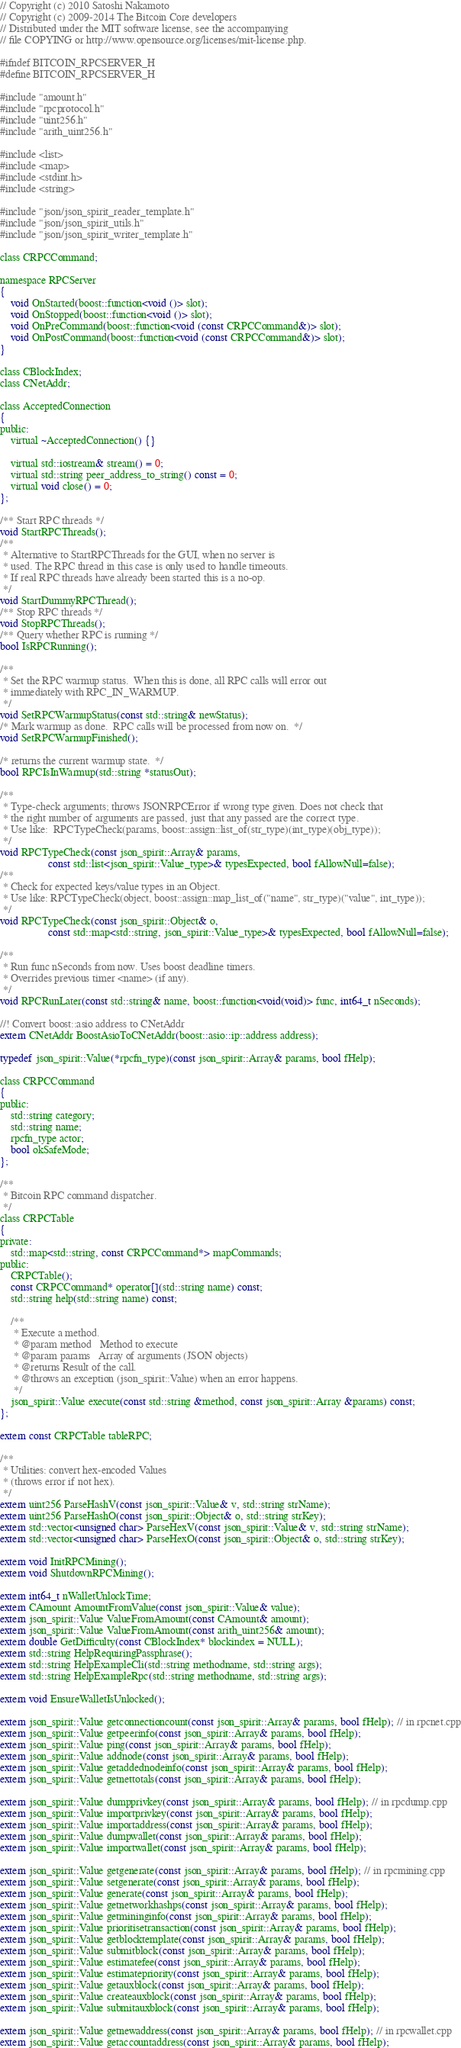Convert code to text. <code><loc_0><loc_0><loc_500><loc_500><_C_>// Copyright (c) 2010 Satoshi Nakamoto
// Copyright (c) 2009-2014 The Bitcoin Core developers
// Distributed under the MIT software license, see the accompanying
// file COPYING or http://www.opensource.org/licenses/mit-license.php.

#ifndef BITCOIN_RPCSERVER_H
#define BITCOIN_RPCSERVER_H

#include "amount.h"
#include "rpcprotocol.h"
#include "uint256.h"
#include "arith_uint256.h"

#include <list>
#include <map>
#include <stdint.h>
#include <string>

#include "json/json_spirit_reader_template.h"
#include "json/json_spirit_utils.h"
#include "json/json_spirit_writer_template.h"

class CRPCCommand;

namespace RPCServer
{
    void OnStarted(boost::function<void ()> slot);
    void OnStopped(boost::function<void ()> slot);
    void OnPreCommand(boost::function<void (const CRPCCommand&)> slot);
    void OnPostCommand(boost::function<void (const CRPCCommand&)> slot);
}

class CBlockIndex;
class CNetAddr;

class AcceptedConnection
{
public:
    virtual ~AcceptedConnection() {}

    virtual std::iostream& stream() = 0;
    virtual std::string peer_address_to_string() const = 0;
    virtual void close() = 0;
};

/** Start RPC threads */
void StartRPCThreads();
/**
 * Alternative to StartRPCThreads for the GUI, when no server is
 * used. The RPC thread in this case is only used to handle timeouts.
 * If real RPC threads have already been started this is a no-op.
 */
void StartDummyRPCThread();
/** Stop RPC threads */
void StopRPCThreads();
/** Query whether RPC is running */
bool IsRPCRunning();

/** 
 * Set the RPC warmup status.  When this is done, all RPC calls will error out
 * immediately with RPC_IN_WARMUP.
 */
void SetRPCWarmupStatus(const std::string& newStatus);
/* Mark warmup as done.  RPC calls will be processed from now on.  */
void SetRPCWarmupFinished();

/* returns the current warmup state.  */
bool RPCIsInWarmup(std::string *statusOut);

/**
 * Type-check arguments; throws JSONRPCError if wrong type given. Does not check that
 * the right number of arguments are passed, just that any passed are the correct type.
 * Use like:  RPCTypeCheck(params, boost::assign::list_of(str_type)(int_type)(obj_type));
 */
void RPCTypeCheck(const json_spirit::Array& params,
                  const std::list<json_spirit::Value_type>& typesExpected, bool fAllowNull=false);
/**
 * Check for expected keys/value types in an Object.
 * Use like: RPCTypeCheck(object, boost::assign::map_list_of("name", str_type)("value", int_type));
 */
void RPCTypeCheck(const json_spirit::Object& o,
                  const std::map<std::string, json_spirit::Value_type>& typesExpected, bool fAllowNull=false);

/**
 * Run func nSeconds from now. Uses boost deadline timers.
 * Overrides previous timer <name> (if any).
 */
void RPCRunLater(const std::string& name, boost::function<void(void)> func, int64_t nSeconds);

//! Convert boost::asio address to CNetAddr
extern CNetAddr BoostAsioToCNetAddr(boost::asio::ip::address address);

typedef json_spirit::Value(*rpcfn_type)(const json_spirit::Array& params, bool fHelp);

class CRPCCommand
{
public:
    std::string category;
    std::string name;
    rpcfn_type actor;
    bool okSafeMode;
};

/**
 * Bitcoin RPC command dispatcher.
 */
class CRPCTable
{
private:
    std::map<std::string, const CRPCCommand*> mapCommands;
public:
    CRPCTable();
    const CRPCCommand* operator[](std::string name) const;
    std::string help(std::string name) const;

    /**
     * Execute a method.
     * @param method   Method to execute
     * @param params   Array of arguments (JSON objects)
     * @returns Result of the call.
     * @throws an exception (json_spirit::Value) when an error happens.
     */
    json_spirit::Value execute(const std::string &method, const json_spirit::Array &params) const;
};

extern const CRPCTable tableRPC;

/**
 * Utilities: convert hex-encoded Values
 * (throws error if not hex).
 */
extern uint256 ParseHashV(const json_spirit::Value& v, std::string strName);
extern uint256 ParseHashO(const json_spirit::Object& o, std::string strKey);
extern std::vector<unsigned char> ParseHexV(const json_spirit::Value& v, std::string strName);
extern std::vector<unsigned char> ParseHexO(const json_spirit::Object& o, std::string strKey);

extern void InitRPCMining();
extern void ShutdownRPCMining();

extern int64_t nWalletUnlockTime;
extern CAmount AmountFromValue(const json_spirit::Value& value);
extern json_spirit::Value ValueFromAmount(const CAmount& amount);
extern json_spirit::Value ValueFromAmount(const arith_uint256& amount);
extern double GetDifficulty(const CBlockIndex* blockindex = NULL);
extern std::string HelpRequiringPassphrase();
extern std::string HelpExampleCli(std::string methodname, std::string args);
extern std::string HelpExampleRpc(std::string methodname, std::string args);

extern void EnsureWalletIsUnlocked();

extern json_spirit::Value getconnectioncount(const json_spirit::Array& params, bool fHelp); // in rpcnet.cpp
extern json_spirit::Value getpeerinfo(const json_spirit::Array& params, bool fHelp);
extern json_spirit::Value ping(const json_spirit::Array& params, bool fHelp);
extern json_spirit::Value addnode(const json_spirit::Array& params, bool fHelp);
extern json_spirit::Value getaddednodeinfo(const json_spirit::Array& params, bool fHelp);
extern json_spirit::Value getnettotals(const json_spirit::Array& params, bool fHelp);

extern json_spirit::Value dumpprivkey(const json_spirit::Array& params, bool fHelp); // in rpcdump.cpp
extern json_spirit::Value importprivkey(const json_spirit::Array& params, bool fHelp);
extern json_spirit::Value importaddress(const json_spirit::Array& params, bool fHelp);
extern json_spirit::Value dumpwallet(const json_spirit::Array& params, bool fHelp);
extern json_spirit::Value importwallet(const json_spirit::Array& params, bool fHelp);

extern json_spirit::Value getgenerate(const json_spirit::Array& params, bool fHelp); // in rpcmining.cpp
extern json_spirit::Value setgenerate(const json_spirit::Array& params, bool fHelp);
extern json_spirit::Value generate(const json_spirit::Array& params, bool fHelp);
extern json_spirit::Value getnetworkhashps(const json_spirit::Array& params, bool fHelp);
extern json_spirit::Value getmininginfo(const json_spirit::Array& params, bool fHelp);
extern json_spirit::Value prioritisetransaction(const json_spirit::Array& params, bool fHelp);
extern json_spirit::Value getblocktemplate(const json_spirit::Array& params, bool fHelp);
extern json_spirit::Value submitblock(const json_spirit::Array& params, bool fHelp);
extern json_spirit::Value estimatefee(const json_spirit::Array& params, bool fHelp);
extern json_spirit::Value estimatepriority(const json_spirit::Array& params, bool fHelp);
extern json_spirit::Value getauxblock(const json_spirit::Array& params, bool fHelp);
extern json_spirit::Value createauxblock(const json_spirit::Array& params, bool fHelp);
extern json_spirit::Value submitauxblock(const json_spirit::Array& params, bool fHelp);

extern json_spirit::Value getnewaddress(const json_spirit::Array& params, bool fHelp); // in rpcwallet.cpp
extern json_spirit::Value getaccountaddress(const json_spirit::Array& params, bool fHelp);</code> 